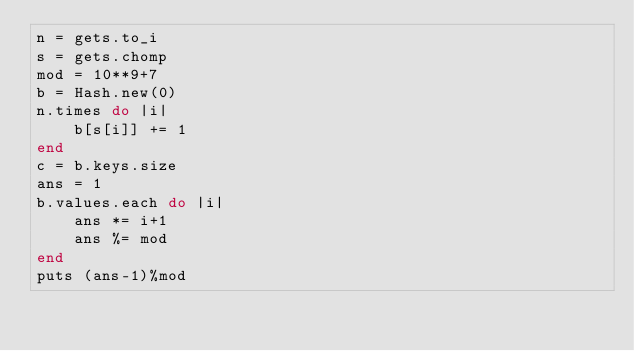<code> <loc_0><loc_0><loc_500><loc_500><_Ruby_>n = gets.to_i
s = gets.chomp
mod = 10**9+7
b = Hash.new(0)
n.times do |i|
    b[s[i]] += 1
end
c = b.keys.size
ans = 1
b.values.each do |i|
    ans *= i+1
    ans %= mod
end
puts (ans-1)%mod</code> 